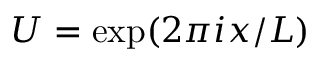Convert formula to latex. <formula><loc_0><loc_0><loc_500><loc_500>U = \exp ( 2 \pi i x / L )</formula> 